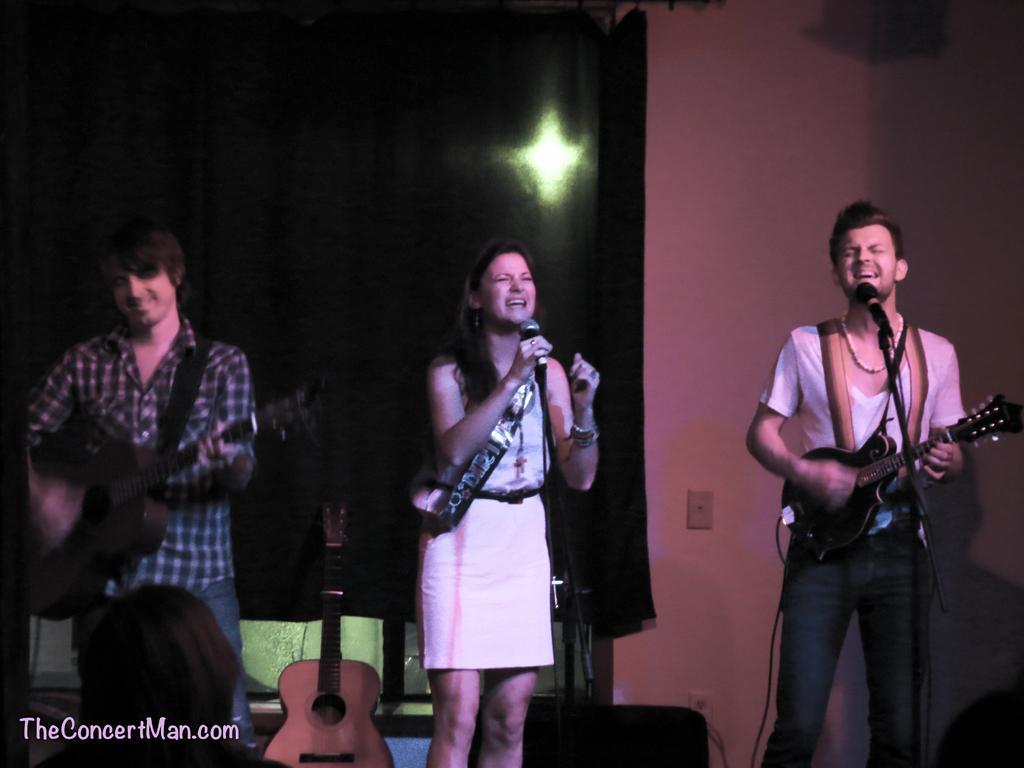Describe this image in one or two sentences. The image is taken in the music concert. There are three people standing in the image. In the center there is a lady standing and holding a mic in her hand she is singing a song. On the left there is a man standing and playing guitar. On the right there is another man playing guitar and singing a song. There is a mic placed before him. In the background there is a wall and curtain. 